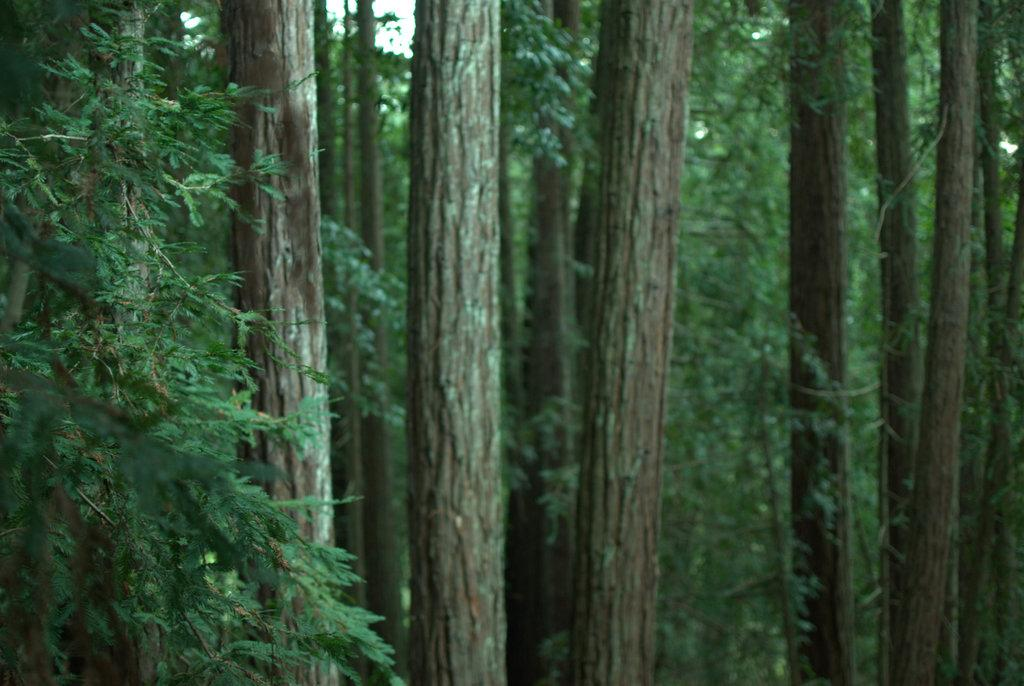What type of vegetation can be seen in the image? There are trees in the image. What part of the trees can be seen in the image? There are leaves in the image. Can you see the ocean in the image? No, there is no ocean present in the image. 